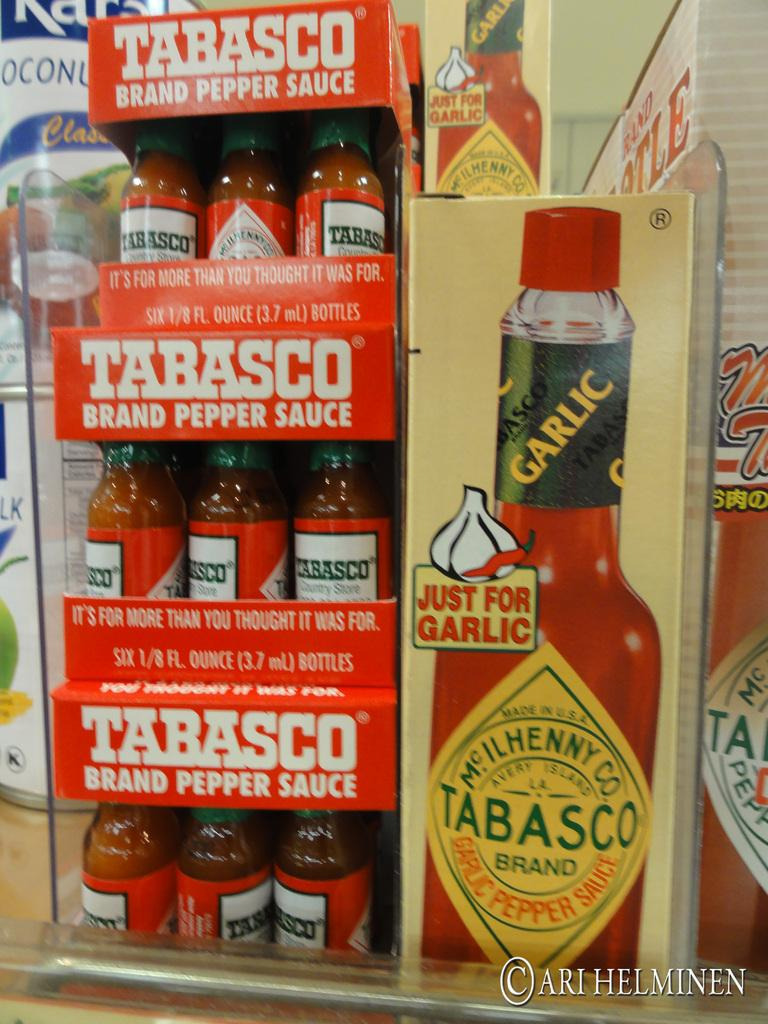What objects are placed on racks in the image? There are bottles placed on racks in the image. What can be seen on the right side of the image? There is a poster with text on the right side of the image. What type of objects are visible in the background of the image? There are cans visible in the background of the image. What type of riddle is being solved by the oven in the image? There is no oven present in the image, and therefore no riddle being solved. 